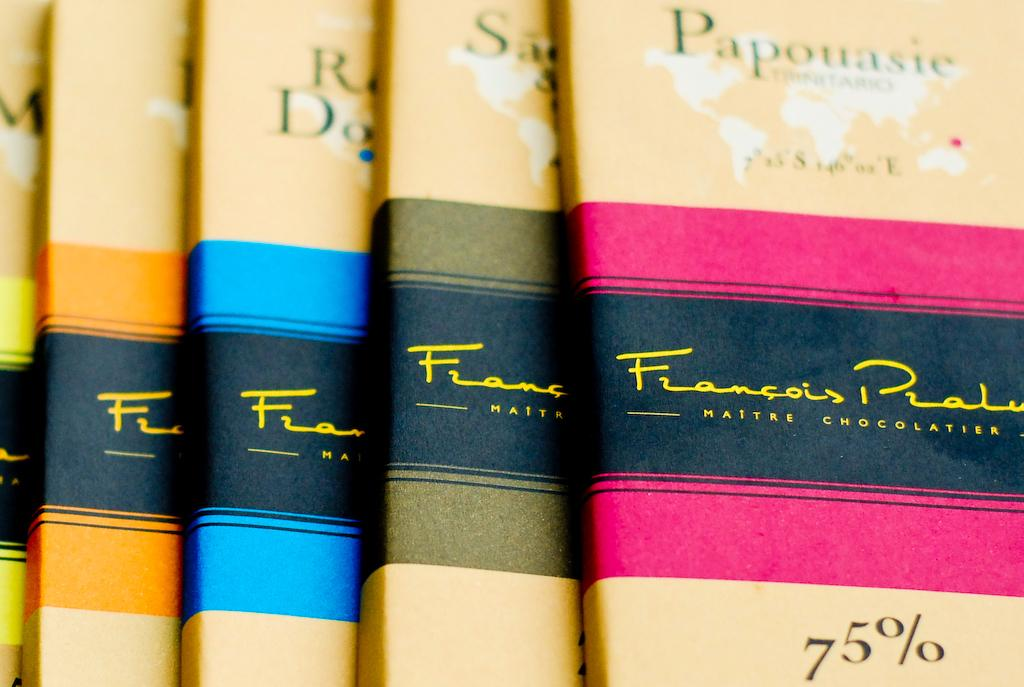<image>
Describe the image concisely. Chocolate labeled Papouasie says that it is 75% chocolate. 